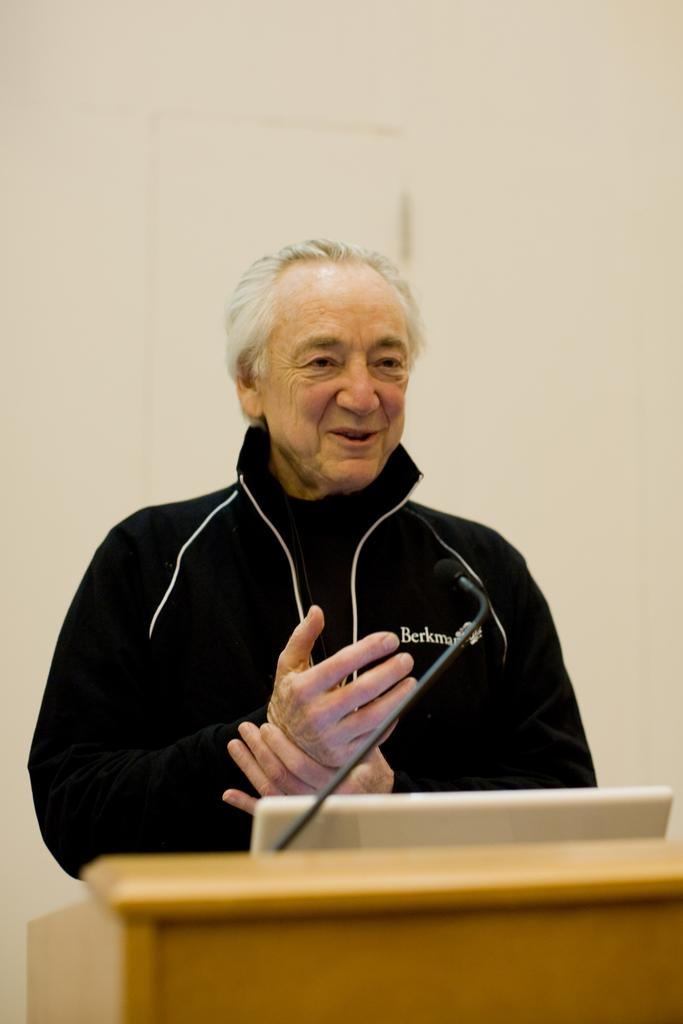Who is present in the image? There is a man in the image. What is the man's proximity to in the image? The man is near a podium. What objects are on the podium? There is a laptop and a microphone on the podium. What can be seen in the background of the image? There is a wall in the background of the image. What is the tendency of the laptop to burn in the image? There is no indication in the image that the laptop is burning or has a tendency to burn. 